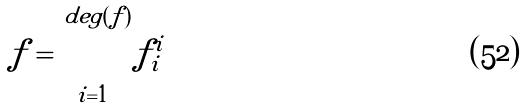<formula> <loc_0><loc_0><loc_500><loc_500>f = \prod _ { i = 1 } ^ { d e g ( f ) } f _ { i } ^ { i }</formula> 